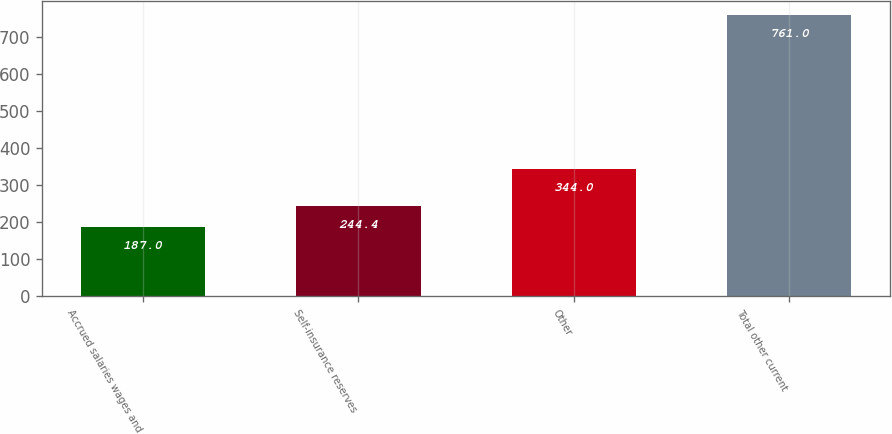Convert chart. <chart><loc_0><loc_0><loc_500><loc_500><bar_chart><fcel>Accrued salaries wages and<fcel>Self-insurance reserves<fcel>Other<fcel>Total other current<nl><fcel>187<fcel>244.4<fcel>344<fcel>761<nl></chart> 